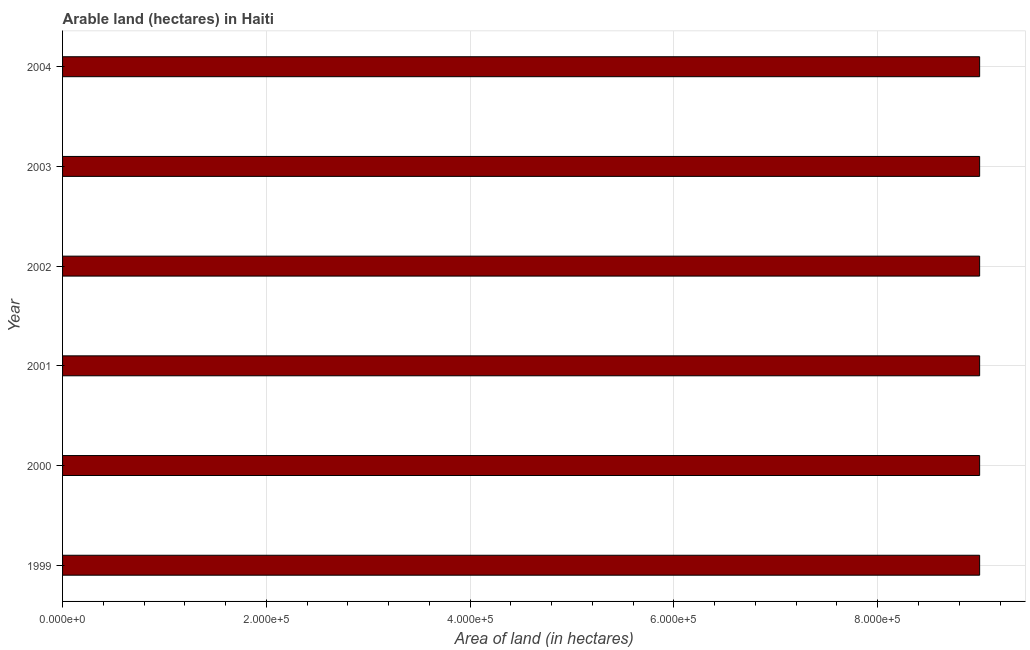Does the graph contain grids?
Provide a succinct answer. Yes. What is the title of the graph?
Provide a succinct answer. Arable land (hectares) in Haiti. What is the label or title of the X-axis?
Your answer should be very brief. Area of land (in hectares). What is the label or title of the Y-axis?
Provide a short and direct response. Year. What is the area of land in 2004?
Your answer should be very brief. 9.00e+05. Across all years, what is the minimum area of land?
Keep it short and to the point. 9.00e+05. In which year was the area of land maximum?
Make the answer very short. 1999. What is the sum of the area of land?
Offer a very short reply. 5.40e+06. What is the average area of land per year?
Ensure brevity in your answer.  9.00e+05. What is the median area of land?
Offer a very short reply. 9.00e+05. In how many years, is the area of land greater than 200000 hectares?
Your answer should be compact. 6. What is the ratio of the area of land in 2001 to that in 2004?
Provide a short and direct response. 1. Is the sum of the area of land in 2001 and 2003 greater than the maximum area of land across all years?
Offer a very short reply. Yes. How many years are there in the graph?
Make the answer very short. 6. What is the Area of land (in hectares) in 2000?
Provide a succinct answer. 9.00e+05. What is the Area of land (in hectares) in 2001?
Give a very brief answer. 9.00e+05. What is the Area of land (in hectares) in 2004?
Provide a succinct answer. 9.00e+05. What is the difference between the Area of land (in hectares) in 1999 and 2003?
Ensure brevity in your answer.  0. What is the difference between the Area of land (in hectares) in 2000 and 2001?
Provide a short and direct response. 0. What is the difference between the Area of land (in hectares) in 2000 and 2003?
Your answer should be compact. 0. What is the difference between the Area of land (in hectares) in 2000 and 2004?
Make the answer very short. 0. What is the difference between the Area of land (in hectares) in 2001 and 2002?
Give a very brief answer. 0. What is the difference between the Area of land (in hectares) in 2001 and 2003?
Your answer should be very brief. 0. What is the difference between the Area of land (in hectares) in 2001 and 2004?
Provide a short and direct response. 0. What is the difference between the Area of land (in hectares) in 2002 and 2004?
Offer a very short reply. 0. What is the ratio of the Area of land (in hectares) in 1999 to that in 2002?
Make the answer very short. 1. What is the ratio of the Area of land (in hectares) in 1999 to that in 2003?
Give a very brief answer. 1. What is the ratio of the Area of land (in hectares) in 2000 to that in 2001?
Keep it short and to the point. 1. What is the ratio of the Area of land (in hectares) in 2000 to that in 2002?
Make the answer very short. 1. What is the ratio of the Area of land (in hectares) in 2000 to that in 2003?
Give a very brief answer. 1. What is the ratio of the Area of land (in hectares) in 2000 to that in 2004?
Provide a short and direct response. 1. What is the ratio of the Area of land (in hectares) in 2001 to that in 2002?
Provide a short and direct response. 1. What is the ratio of the Area of land (in hectares) in 2001 to that in 2003?
Your answer should be very brief. 1. What is the ratio of the Area of land (in hectares) in 2002 to that in 2003?
Your response must be concise. 1. What is the ratio of the Area of land (in hectares) in 2002 to that in 2004?
Your answer should be very brief. 1. 